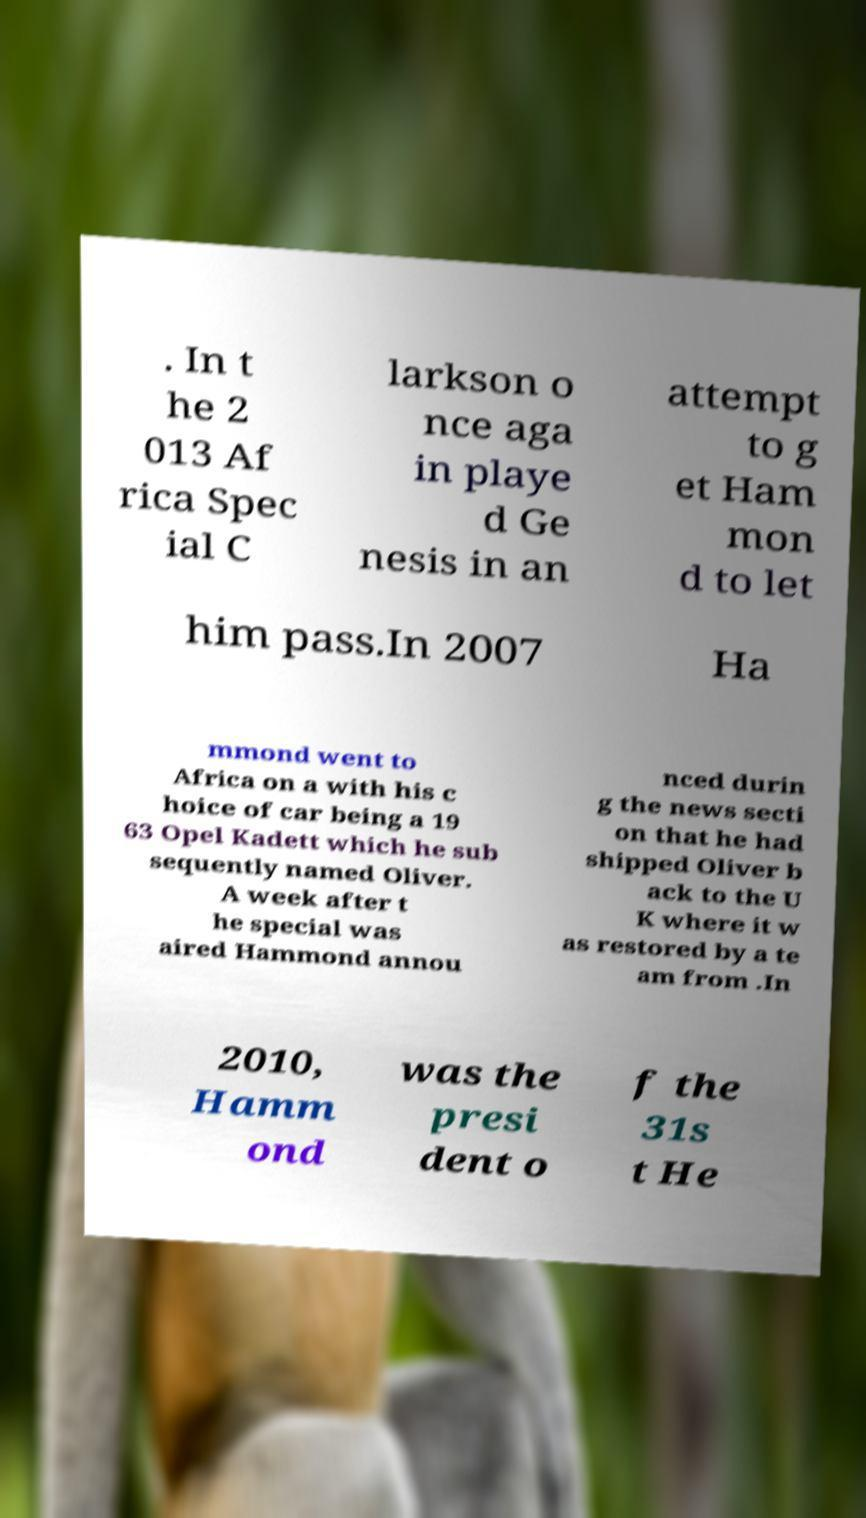There's text embedded in this image that I need extracted. Can you transcribe it verbatim? . In t he 2 013 Af rica Spec ial C larkson o nce aga in playe d Ge nesis in an attempt to g et Ham mon d to let him pass.In 2007 Ha mmond went to Africa on a with his c hoice of car being a 19 63 Opel Kadett which he sub sequently named Oliver. A week after t he special was aired Hammond annou nced durin g the news secti on that he had shipped Oliver b ack to the U K where it w as restored by a te am from .In 2010, Hamm ond was the presi dent o f the 31s t He 